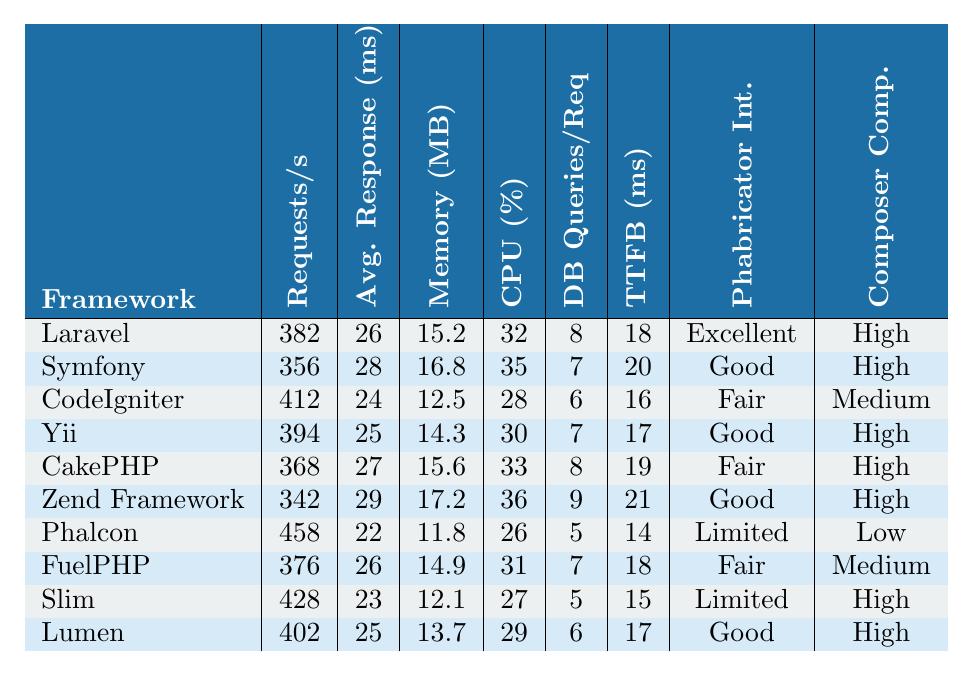What is the requests per second for Laravel? The table lists that Laravel has 382 requests per second in the relevant column.
Answer: 382 Which framework has the lowest memory usage? By examining the memory usage column, Phalcon has the lowest memory usage at 11.8 MB.
Answer: 11.8 MB What is the average response time for Yii? The average response time for Yii is found in its respective row, which indicates 25 milliseconds.
Answer: 25 ms Which framework has the highest CPU usage? Zend Framework shows the highest CPU usage at 36%.
Answer: 36% What is the total number of database queries per request for Slim and Phalcon? For Slim, the database queries per request is 5, and for Phalcon, it is also 5. The total is 5 + 5 = 10.
Answer: 10 Is Laravel better than CodeIgniter in terms of requests per second? Laravel has 382 requests per second while CodeIgniter has 412. Since 412 is greater, CodeIgniter is better in this aspect.
Answer: No What is the difference in requests per second between the best and worst-performing frameworks? Phalcon has the highest requests per second with 458, while Zend Framework has the lowest with 342. The difference is 458 - 342 = 116.
Answer: 116 Which framework has a good Phabricator integration but lower memory usage than Yii? Yii has a good Phabricator integration and memory usage of 14.3 MB, whereas Lumen also has good integration and a lower memory usage of 13.7 MB.
Answer: Lumen What is the sum of requests per second for Laravel, Yii, and Lumen? The requests per second for Laravel is 382, for Yii is 394, and for Lumen is 402. Summing these gives 382 + 394 + 402 = 1178.
Answer: 1178 Is it true that all frameworks with a "Good" Phabricator integration have high composer compatibility? Symfony, Yii, Lumen, and Zend Framework all have "Good" integration, and they also have high composer compatibility. This indicates that the statement is true.
Answer: Yes 